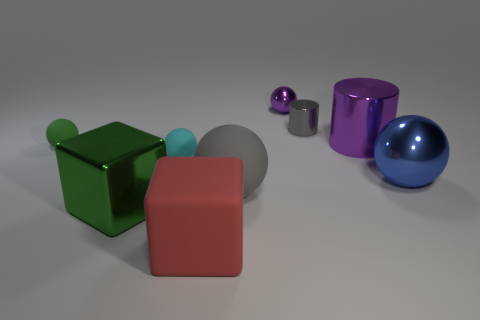Add 1 tiny blue metallic things. How many objects exist? 10 Subtract all big gray spheres. How many spheres are left? 4 Subtract all cyan balls. How many balls are left? 4 Subtract all purple cylinders. How many brown blocks are left? 0 Subtract all small yellow rubber cubes. Subtract all purple metal spheres. How many objects are left? 8 Add 2 gray matte things. How many gray matte things are left? 3 Add 5 large red rubber objects. How many large red rubber objects exist? 6 Subtract 0 yellow cylinders. How many objects are left? 9 Subtract all cylinders. How many objects are left? 7 Subtract 1 cylinders. How many cylinders are left? 1 